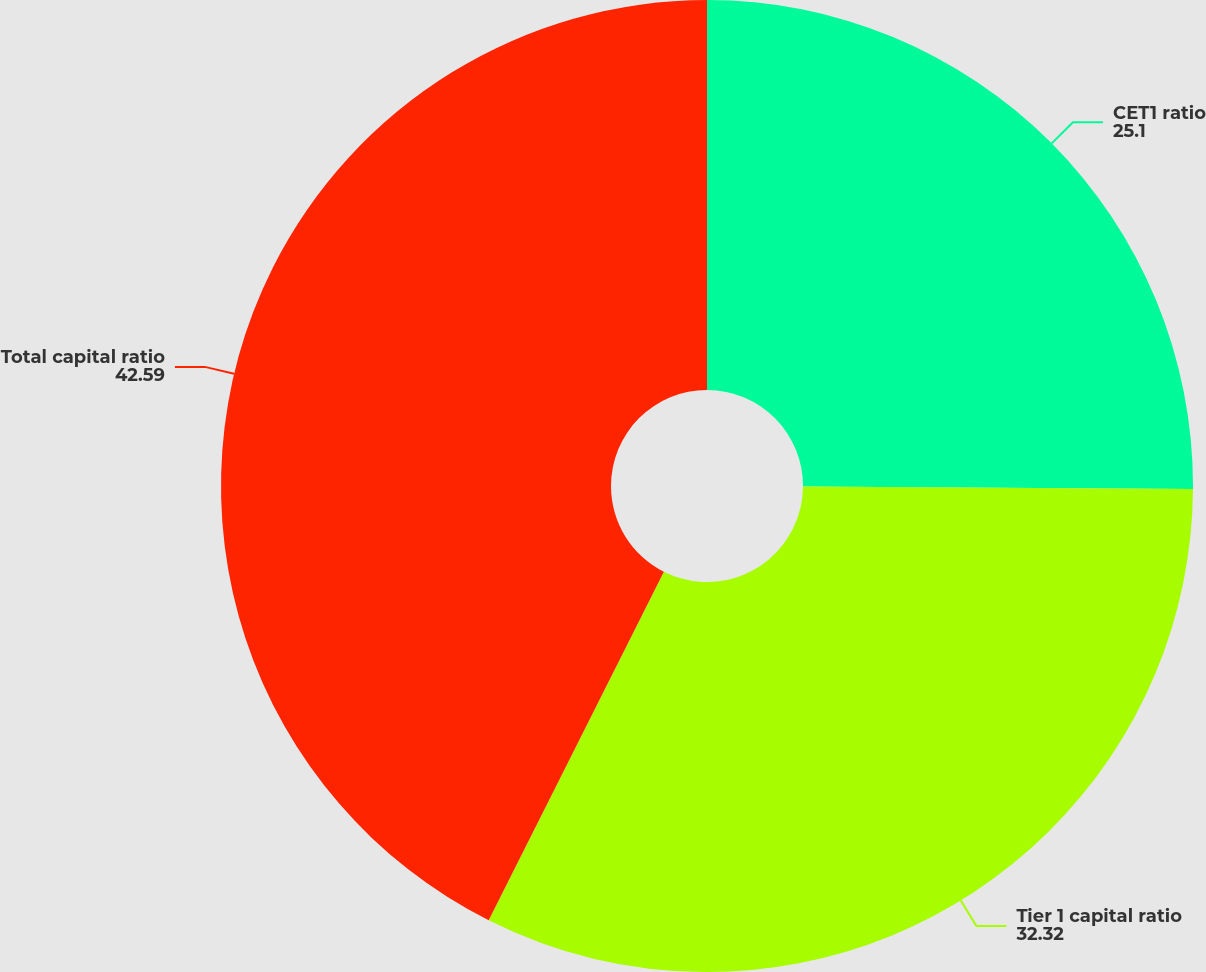Convert chart to OTSL. <chart><loc_0><loc_0><loc_500><loc_500><pie_chart><fcel>CET1 ratio<fcel>Tier 1 capital ratio<fcel>Total capital ratio<nl><fcel>25.1%<fcel>32.32%<fcel>42.59%<nl></chart> 